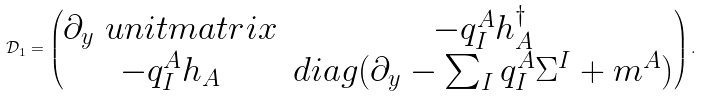Convert formula to latex. <formula><loc_0><loc_0><loc_500><loc_500>\mathcal { D } _ { 1 } = \begin{pmatrix} \partial _ { y } \ u n i t m a t r i x & - q _ { I } ^ { A } h _ { A } ^ { \dagger } \\ - q _ { I } ^ { A } h _ { A } & d i a g ( \partial _ { y } - \sum _ { I } q _ { I } ^ { A } \Sigma ^ { I } + m ^ { A } ) \end{pmatrix} .</formula> 